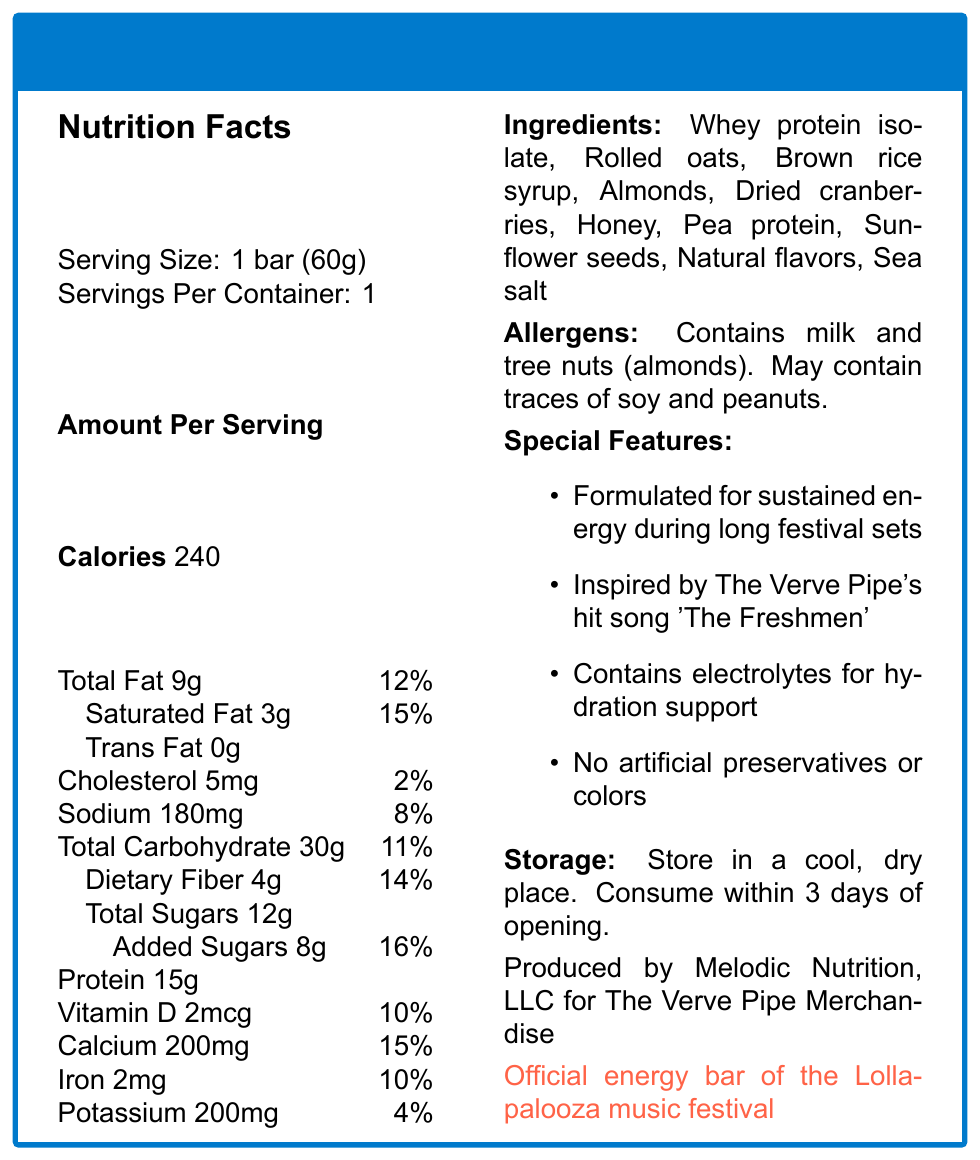what is the serving size of The Freshmen Energy Bar? The serving size is explicitly mentioned as "1 bar (60g)" in the document.
Answer: 1 bar (60g) how many calories are in one serving of The Freshmen Energy Bar? The document states the calories per serving as 240.
Answer: 240 what percentage of the daily value of iron does The Freshmen Energy Bar provide? The document lists iron as providing 10% of the daily value.
Answer: 10% List three ingredients found in The Freshmen Energy Bar. These ingredients are mentioned in the Ingredients section of the document.
Answer: Whey protein isolate, Rolled oats, Almonds what is the daily value percentage for saturated fat in The Freshmen Energy Bar? The document indicates that the saturated fat daily value percentage is 15%.
Answer: 15% what are the special features of The Freshmen Energy Bar? A. Includes artificial preservatives B. Inspired by The Verve Pipe's song C. Contain electrolytes D. Includes colors The document highlights that it is inspired by The Verve Pipe's song and contains electrolytes for hydration support. It specifically mentions no artificial preservatives or colors.
Answer: B and C which allergen is definitely present in The Freshmen Energy Bar? 1. Soy 2. Peanuts 3. Almonds 4. Wheat The document states that the bar contains milk and tree nuts (almonds).
Answer: 3. Almonds Is The Freshmen Energy Bar free of trans fat? The document confirms that the trans fat content is 0g.
Answer: Yes summarize the main idea of this document. The document gives a complete overview of the product, focusing on nutritional values, special features, and its partnership with Lollapalooza.
Answer: The Freshmen Energy Bar is a protein bar inspired by The Verve Pipe's hit song, formulated for sustained energy during music festivals. It provides nutritional information, ingredients, allergens, features, storage instructions, and is the official bar of the Lollapalooza music festival. Who is the main distributor for The Freshmen Energy Bar? The document lists the manufacturer (Melodic Nutrition, LLC for The Verve Pipe Merchandise), but not the main distributor.
Answer: Cannot be determined 